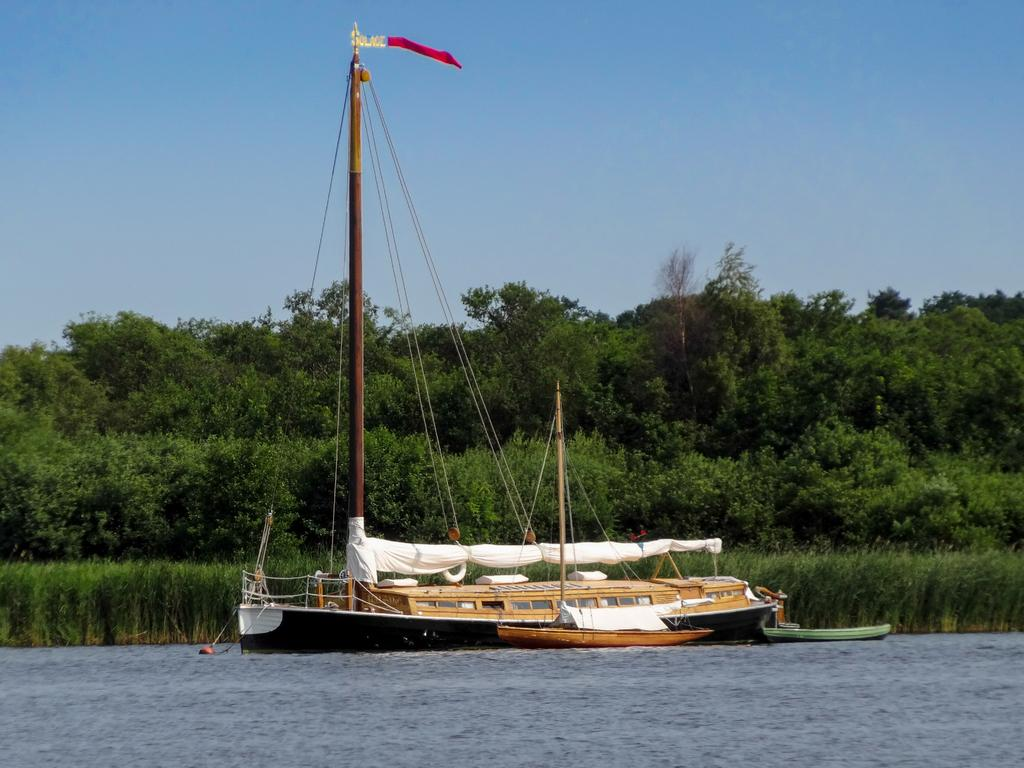Where was the picture taken? The picture was clicked outside the city. What is the main subject in the center of the image? There is a ship in the water body in the center of the image. What can be seen in the background of the image? The sky, trees, and plants are visible in the background of the image. What color are the toes of the person standing on the ship in the image? There are no people or toes visible in the image; it only shows a ship in the water body. 